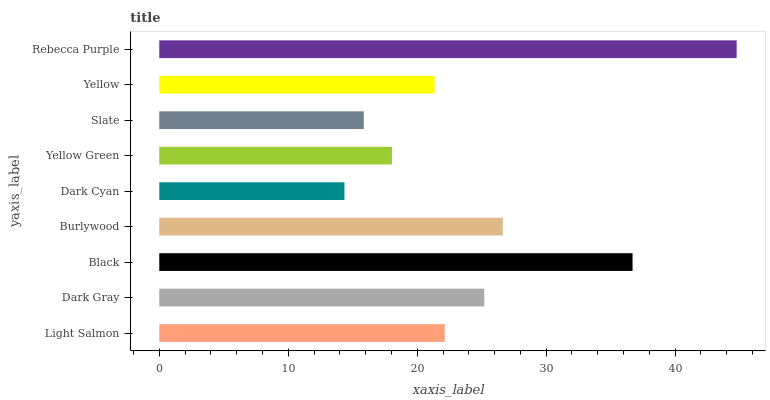Is Dark Cyan the minimum?
Answer yes or no. Yes. Is Rebecca Purple the maximum?
Answer yes or no. Yes. Is Dark Gray the minimum?
Answer yes or no. No. Is Dark Gray the maximum?
Answer yes or no. No. Is Dark Gray greater than Light Salmon?
Answer yes or no. Yes. Is Light Salmon less than Dark Gray?
Answer yes or no. Yes. Is Light Salmon greater than Dark Gray?
Answer yes or no. No. Is Dark Gray less than Light Salmon?
Answer yes or no. No. Is Light Salmon the high median?
Answer yes or no. Yes. Is Light Salmon the low median?
Answer yes or no. Yes. Is Dark Cyan the high median?
Answer yes or no. No. Is Dark Gray the low median?
Answer yes or no. No. 